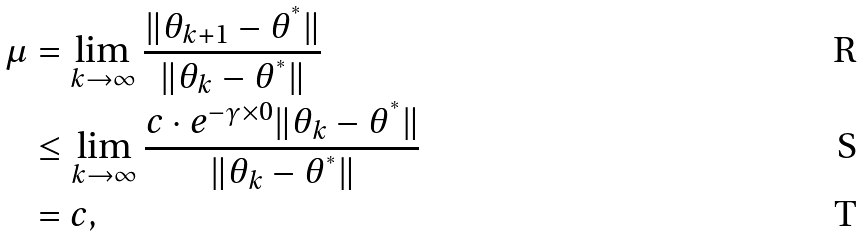Convert formula to latex. <formula><loc_0><loc_0><loc_500><loc_500>\mu & = \lim _ { k \to \infty } \frac { \| \theta _ { k + 1 } - \theta ^ { ^ { * } } \| } { \| \theta _ { k } - \theta ^ { ^ { * } } \| } \\ & \leq \lim _ { k \to \infty } \frac { c \cdot e ^ { - \gamma \times 0 } \| \theta _ { k } - \theta ^ { ^ { * } } \| } { \| \theta _ { k } - \theta ^ { ^ { * } } \| } \\ & = c ,</formula> 